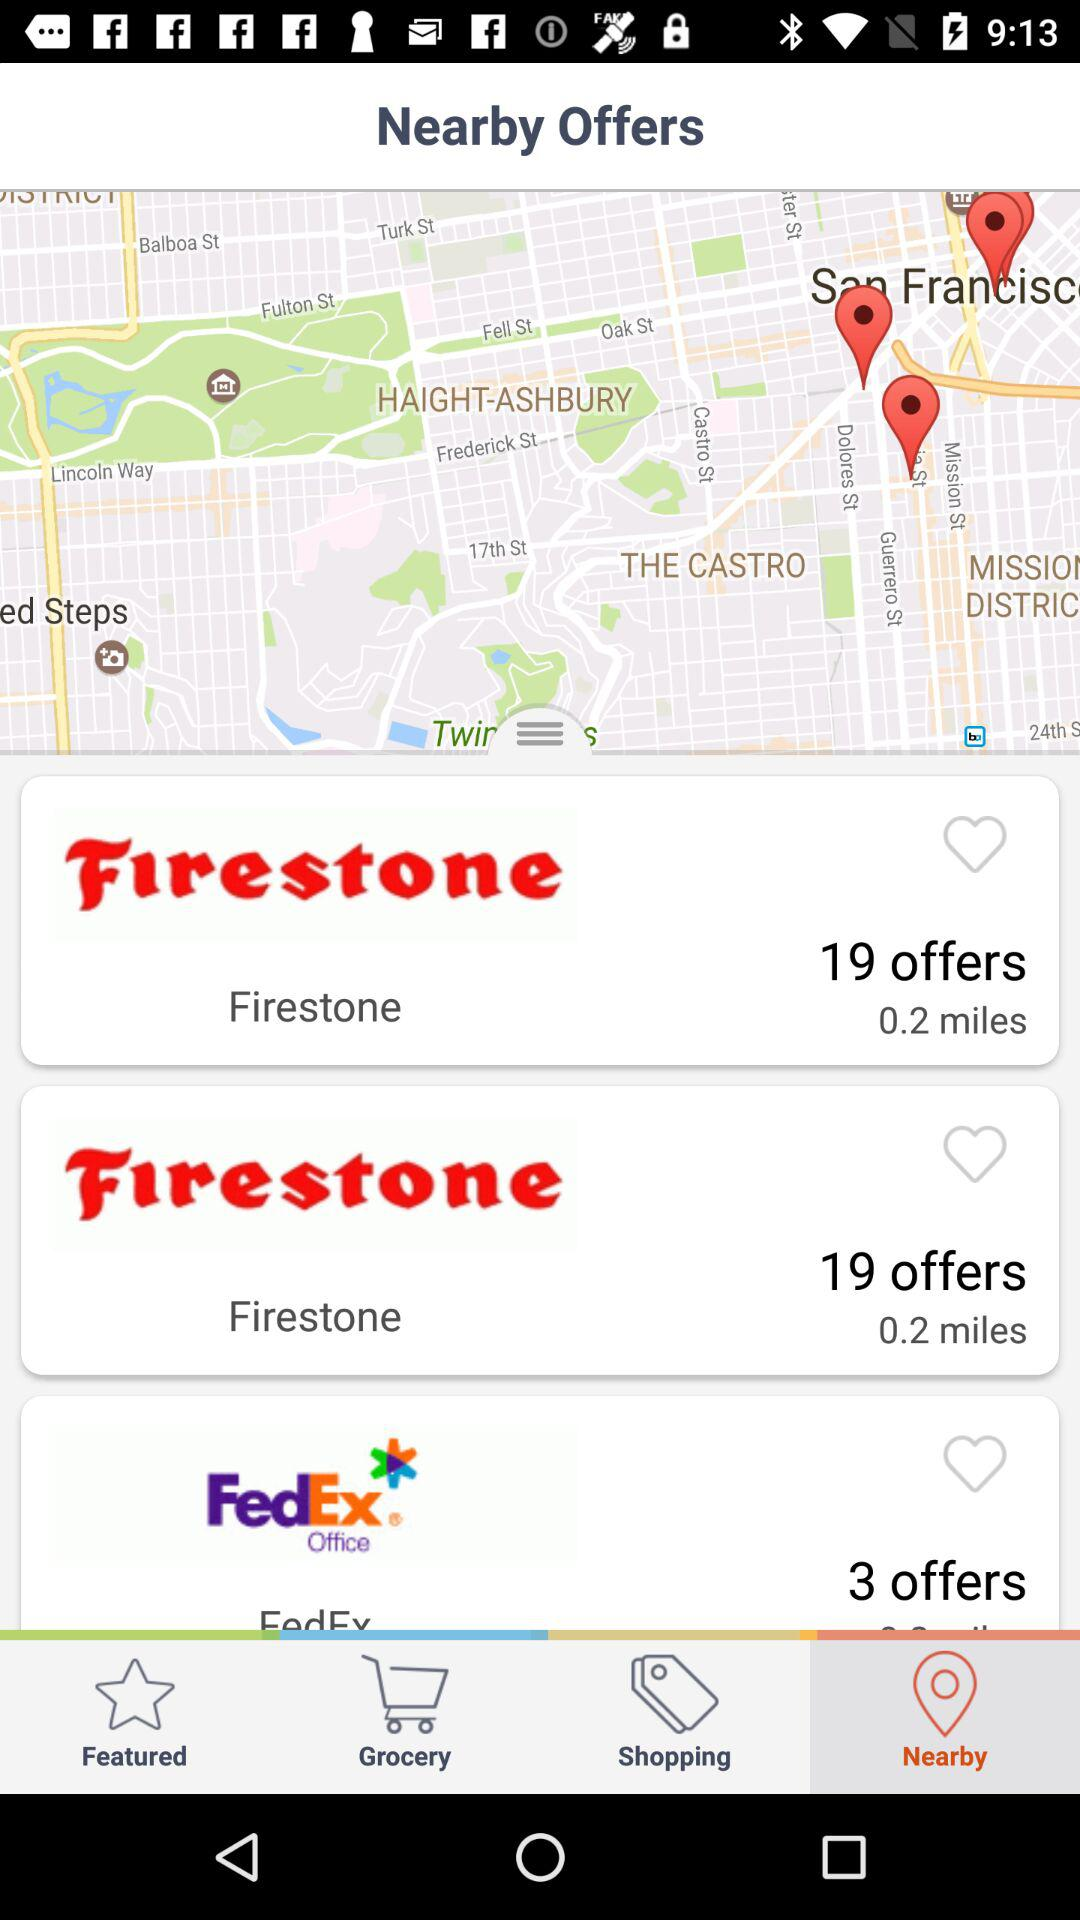How many more offers does Firestone have than FedEx?
Answer the question using a single word or phrase. 16 